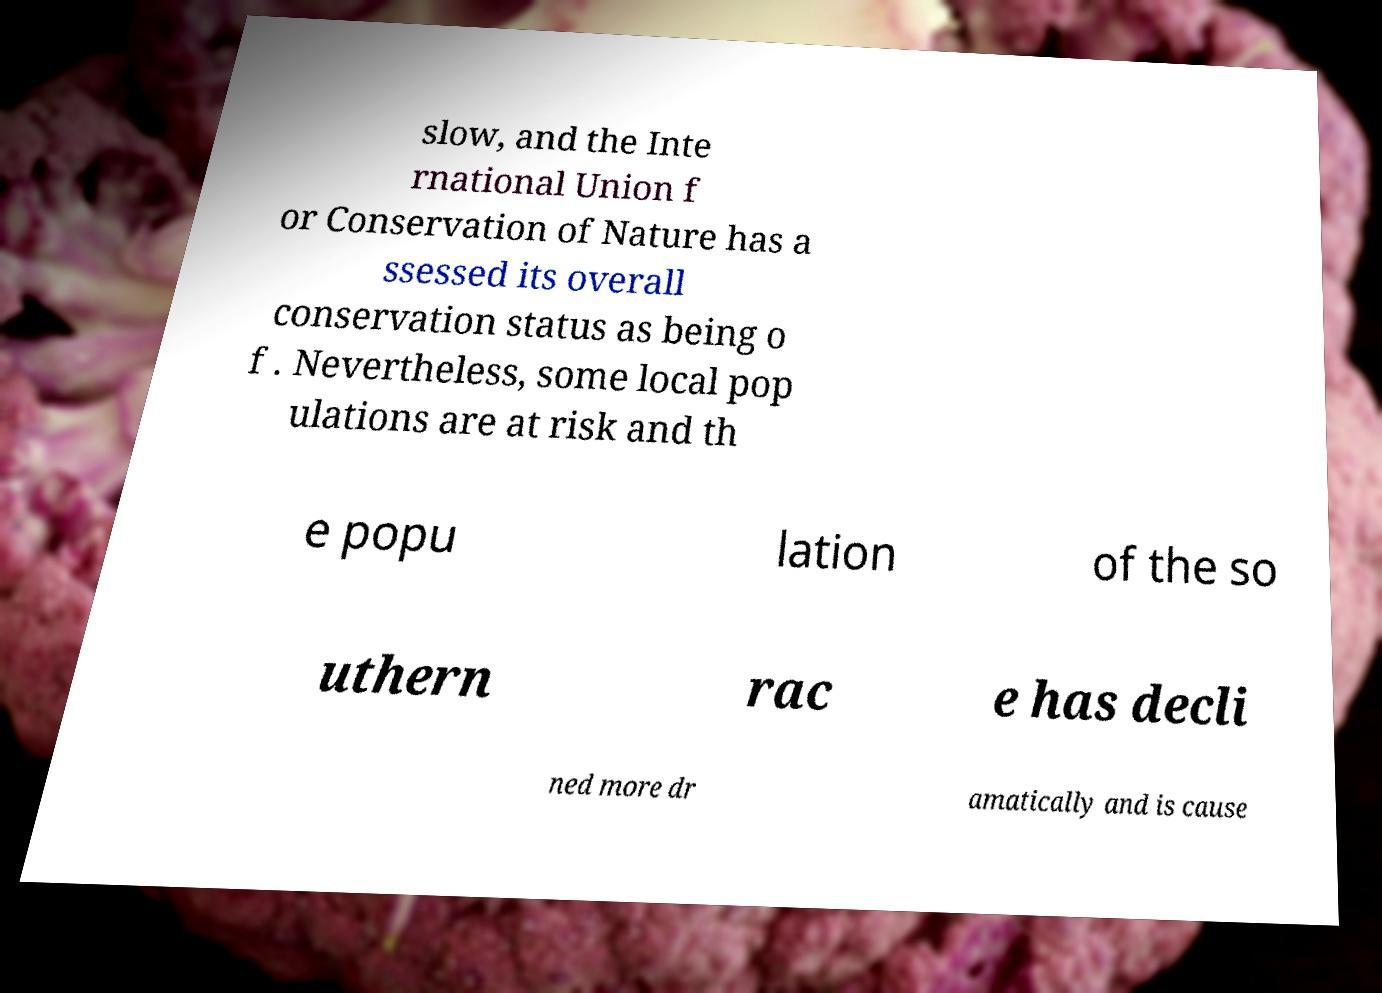For documentation purposes, I need the text within this image transcribed. Could you provide that? slow, and the Inte rnational Union f or Conservation of Nature has a ssessed its overall conservation status as being o f . Nevertheless, some local pop ulations are at risk and th e popu lation of the so uthern rac e has decli ned more dr amatically and is cause 